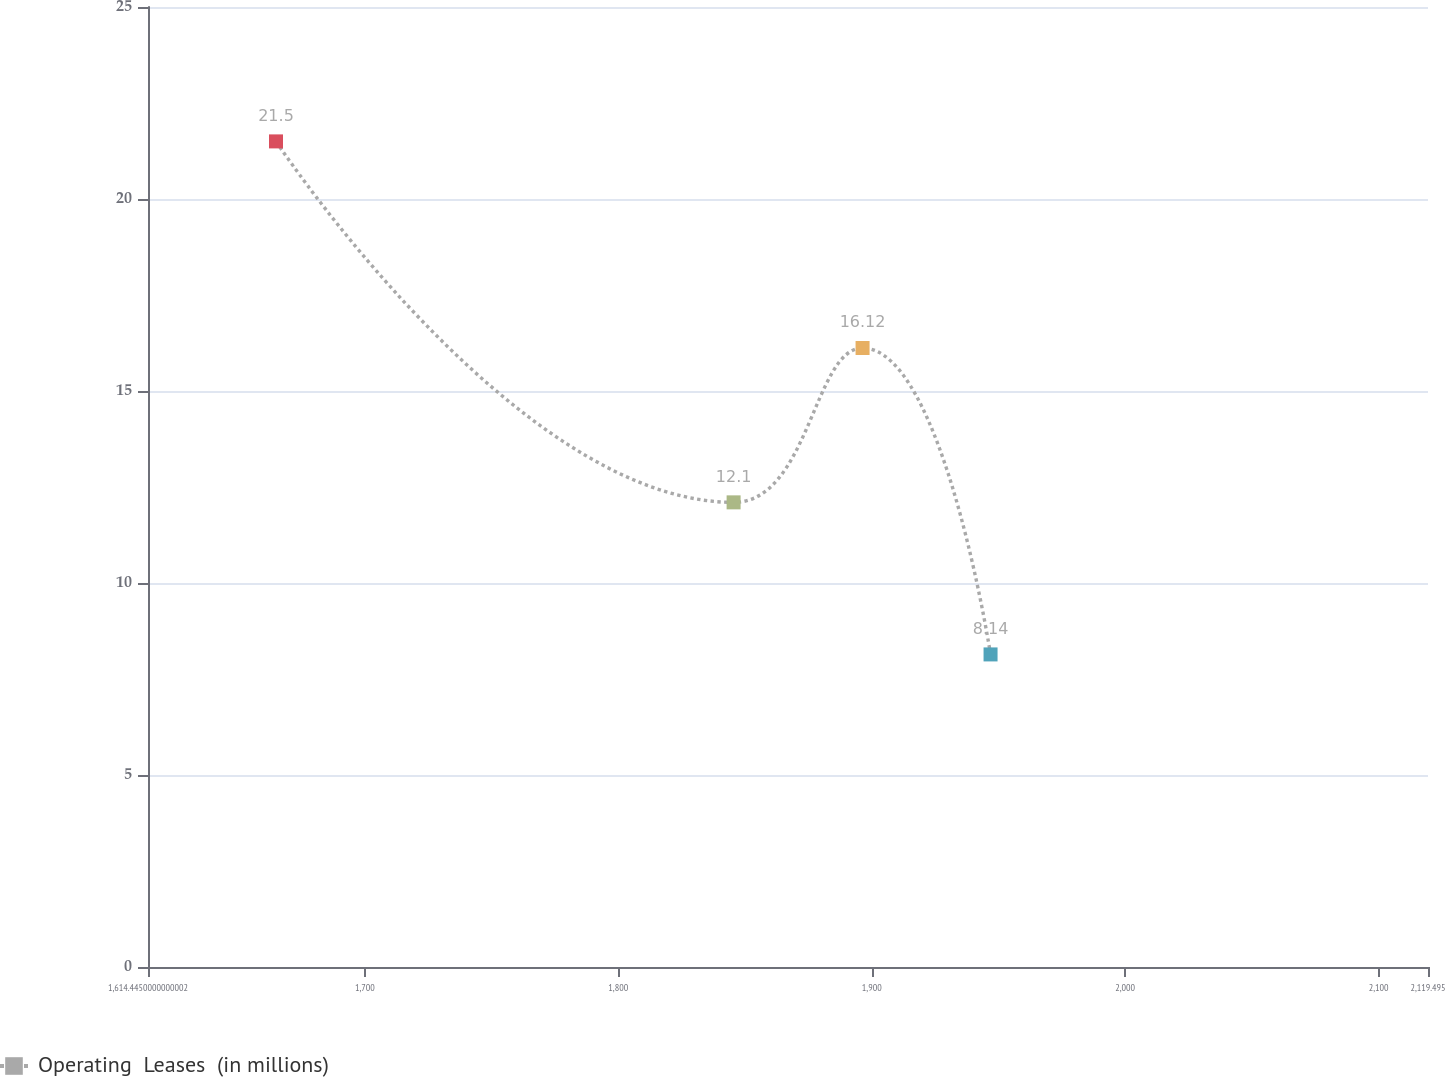Convert chart. <chart><loc_0><loc_0><loc_500><loc_500><line_chart><ecel><fcel>Operating  Leases  (in millions)<nl><fcel>1664.95<fcel>21.5<nl><fcel>1845.51<fcel>12.1<nl><fcel>1896.39<fcel>16.12<nl><fcel>1946.89<fcel>8.14<nl><fcel>2170<fcel>9.48<nl></chart> 